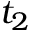<formula> <loc_0><loc_0><loc_500><loc_500>t _ { 2 }</formula> 